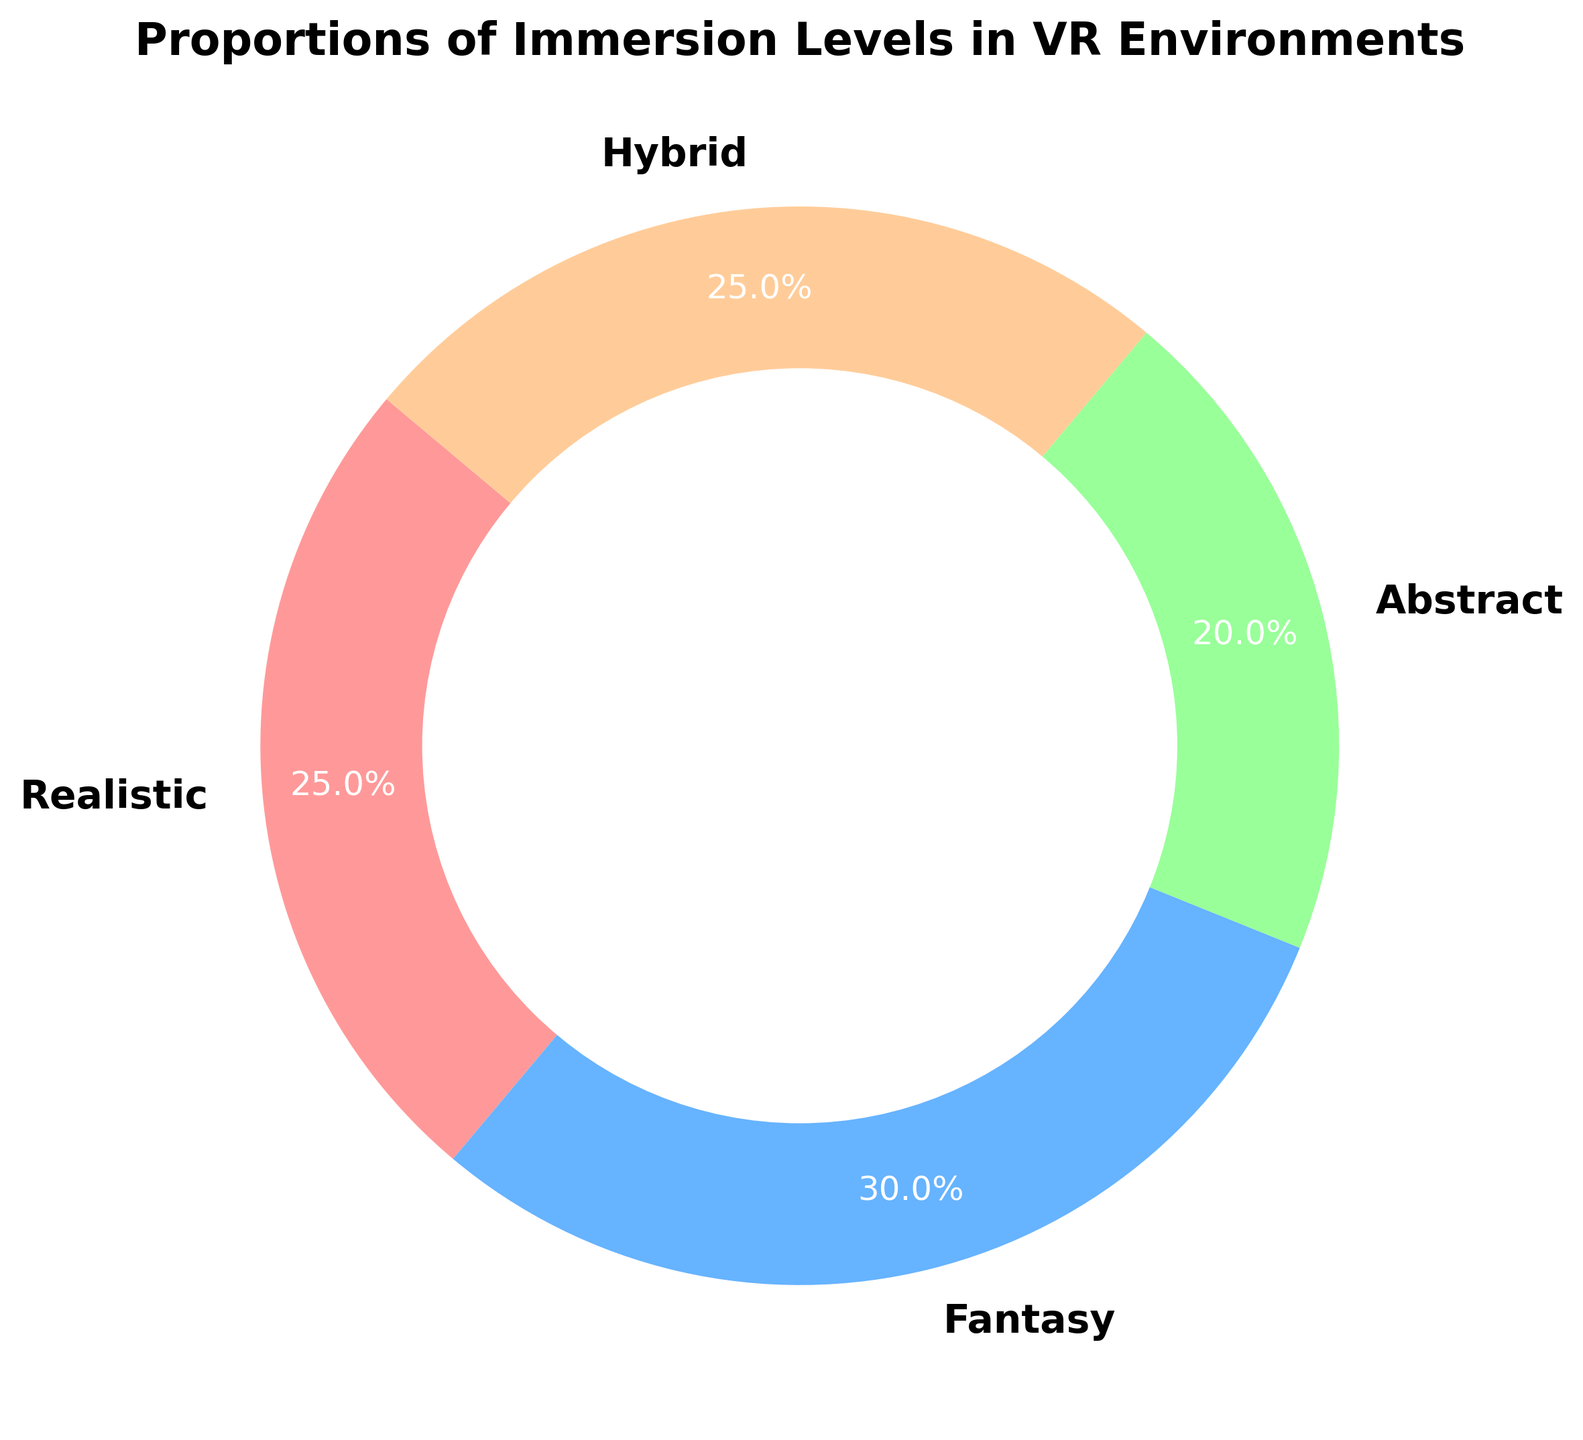Which immersion level is the most common in the VR environments? By observing the pie chart, the Fantasy segment has the largest slice which indicates it is the most common.
Answer: Fantasy Which two immersion levels have equal proportions? The pie chart shows that Realistic and Hybrid segments both occupy identical proportions of the pie.
Answer: Realistic and Hybrid What is the combined proportion of Realistic and Abstract immersion levels? The Realistic and Abstract slices represent 25% and 20% of the pie, respectively, totaling 25% + 20% = 45%.
Answer: 45% Is the proportion of Fantasy immersion level greater than the proportion of Abstract immersion level? By comparing the slices, the Fantasy slice (30%) is greater than the Abstract slice (20%).
Answer: Yes What is the difference between the proportions of Hybrid and Abstract immersion levels? The Hybrid slice is 25% and the Abstract slice is 20%, so the difference is 25% - 20% = 5%.
Answer: 5% If you combine the proportions of Realistic and Hybrid, how does it compare to the proportion of Fantasy immersion? The combined proportion of Realistic and Hybrid is 25% + 25% = 50%, which is greater than the Fantasy proportion of 30%.
Answer: Combined is greater Which immersion level has the smallest proportion in the VR environments? The pie chart shows that the Abstract slice has the smallest proportion of 20%.
Answer: Abstract What are the visual colors used to represent Realistic and Fantasy immersion levels? From the pie chart, the Realistic slice is represented by a pinkish color and the Fantasy slice is represented by a blue color.
Answer: pinkish for Realistic, blue for Fantasy How many immersion levels have a proportion less than 30%? By examining the slices, Realistic (25%), Abstract (20%), and Hybrid (25%) are all less than 30%, totaling three immersion levels.
Answer: Three 